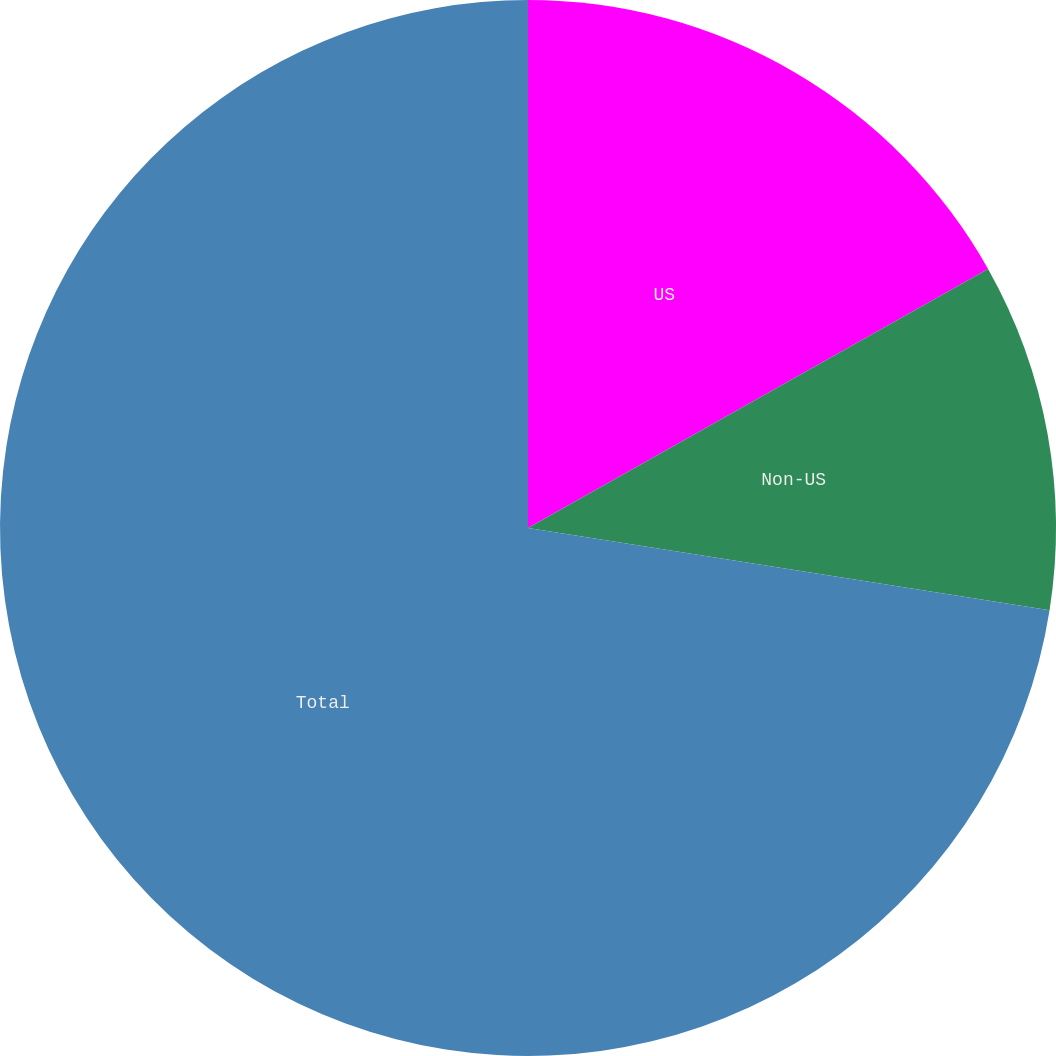Convert chart to OTSL. <chart><loc_0><loc_0><loc_500><loc_500><pie_chart><fcel>US<fcel>Non-US<fcel>Total<nl><fcel>16.84%<fcel>10.65%<fcel>72.52%<nl></chart> 